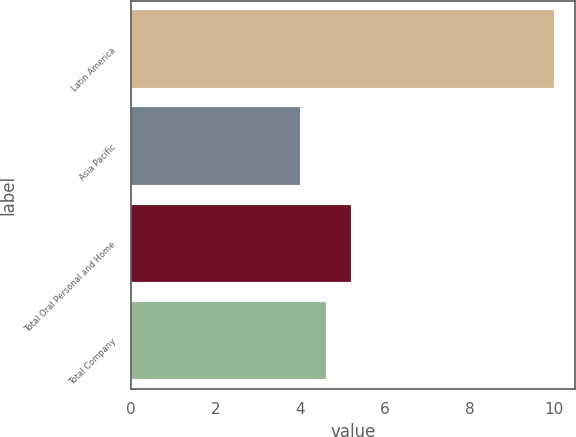<chart> <loc_0><loc_0><loc_500><loc_500><bar_chart><fcel>Latin America<fcel>Asia Pacific<fcel>Total Oral Personal and Home<fcel>Total Company<nl><fcel>10<fcel>4<fcel>5.2<fcel>4.6<nl></chart> 